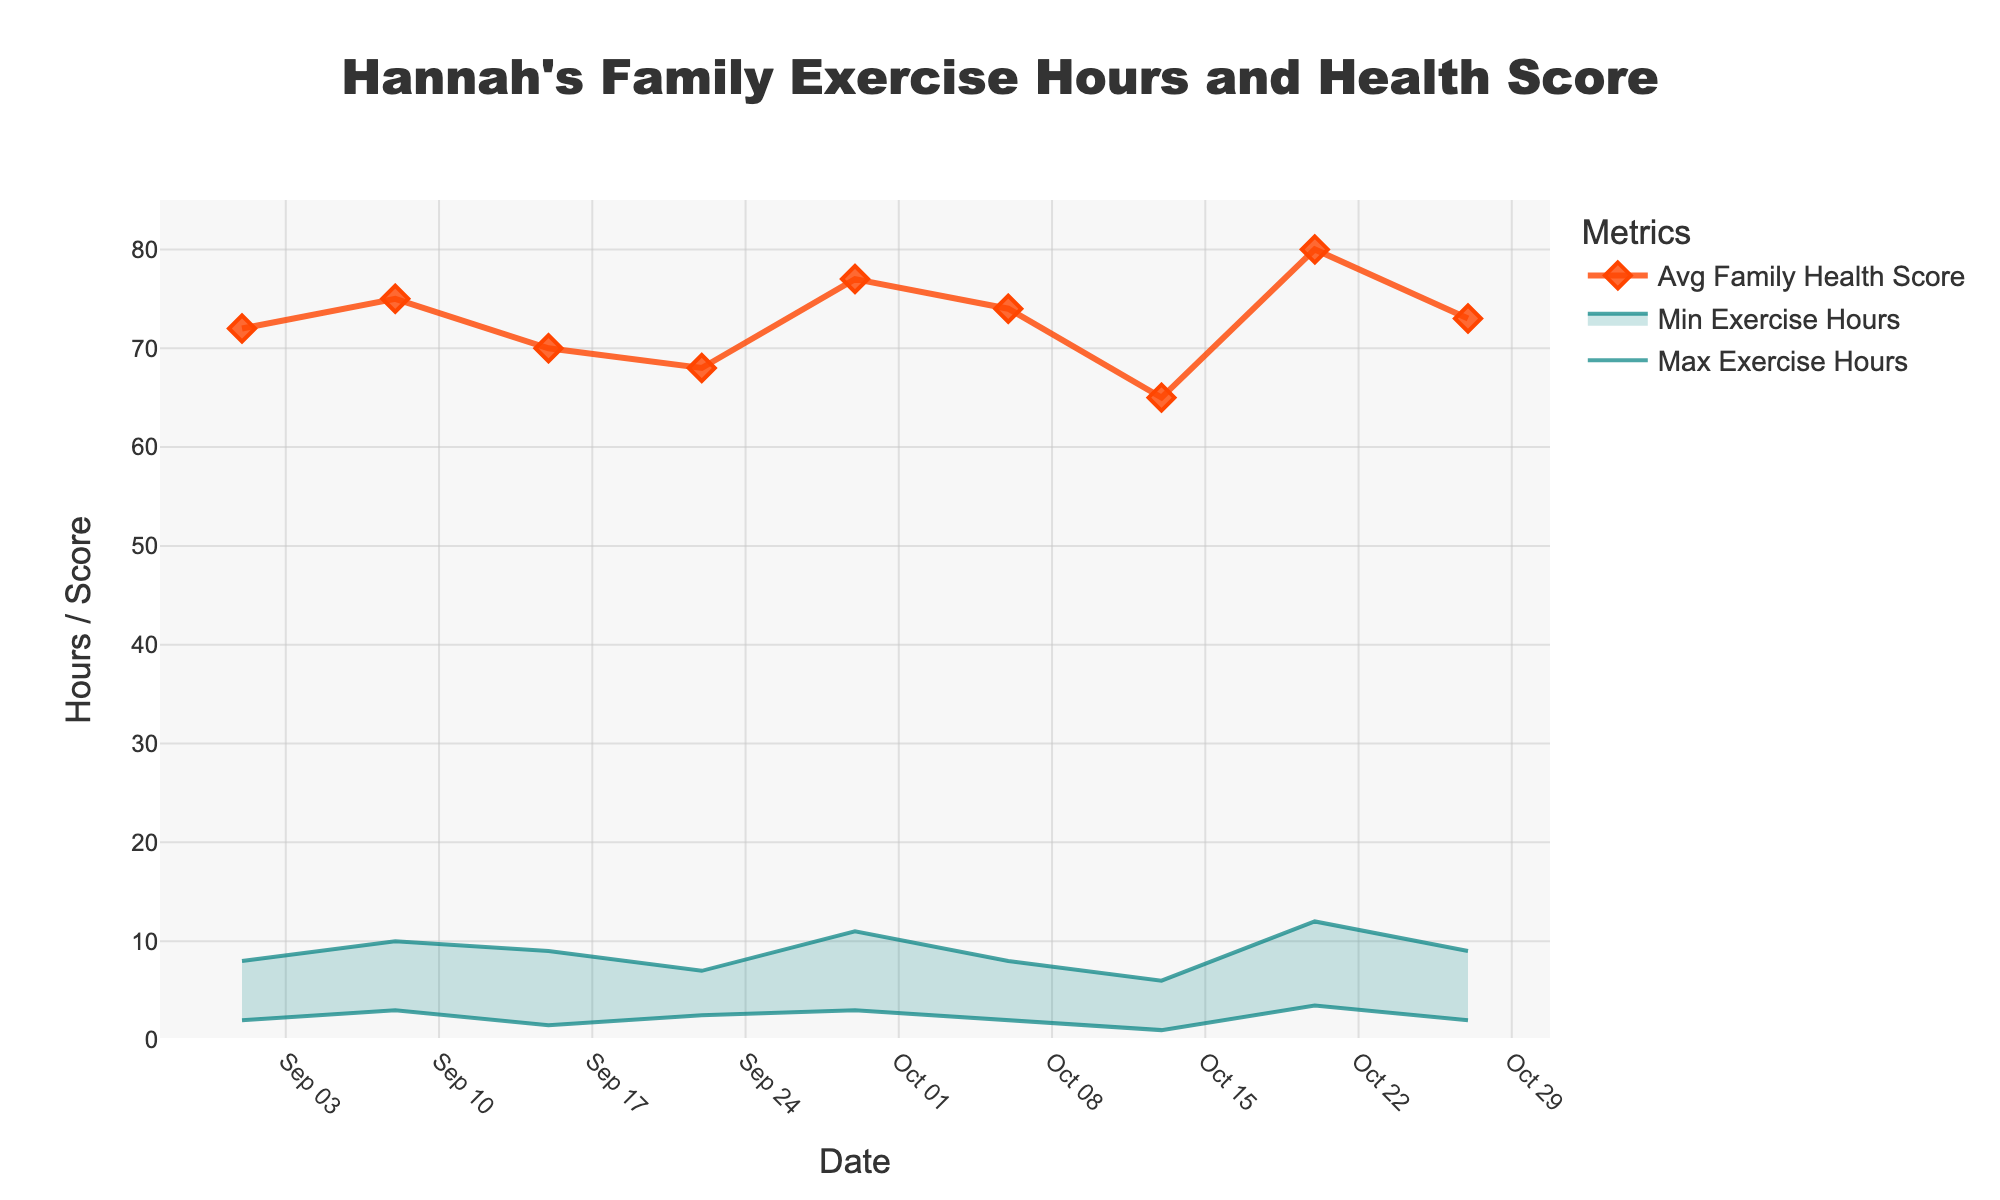What is the title of the chart? The title of the chart is located at the top center of the figure. It is stylized in a large, bold, and black font.
Answer: Hannah's Family Exercise Hours and Health Score How many data points are represented in the chart? By observing the x-axis labels and the marked data points on the lines, one can count the number of distinct dates.
Answer: 9 What date shows the highest maximum exercise hours? Look at the 'Max Exercise Hours' line and identify the peak value and its corresponding date on the x-axis.
Answer: 2023-10-20 Which date shows the lowest average family health score? Examine the 'Avg Family Health Score' line. The point on the y-axis representing the lowest value will correspond to a date on the x-axis.
Answer: 2023-10-13 Compare the range of exercise hours between 2023-10-13 and 2023-09-22. Which date shows a wider range? Calculate the ranges for each date (Max - Min). The date with the larger difference has the wider range.
Answer: 2023-09-22 What is the difference in average family health score between 2023-09-01 and 2023-10-20? Identify the scores for both dates and calculate the difference (80 - 72).
Answer: 8 What is the average of the maximum exercise hours recorded? Sum the maximum exercise hours for all dates and divide by the number of dates. (8 + 10 + 9 + 7 + 11 + 8 + 6 + 12 + 9) / 9
Answer: 8.89 Which week shows the smallest range between minimum and maximum exercise hours? Compare the differences (Max - Min) for each week. The smallest difference indicates the smallest range.
Answer: 2023-10-13 Is there a visible trend between exercise hours and family health scores? By observing how the 'Min' and 'Max Exercise Hours' areas overlap with the 'Avg Family Health Score' line, assess if higher exercise generally coincides with higher family health scores.
Answer: Yes, generally higher exercise correlates with better family health What is the total sum of the average family health scores for all weeks? Add the average family health scores for each date. (72 + 75 + 70 + 68 + 77 + 74 + 65 + 80 + 73)
Answer: 654 